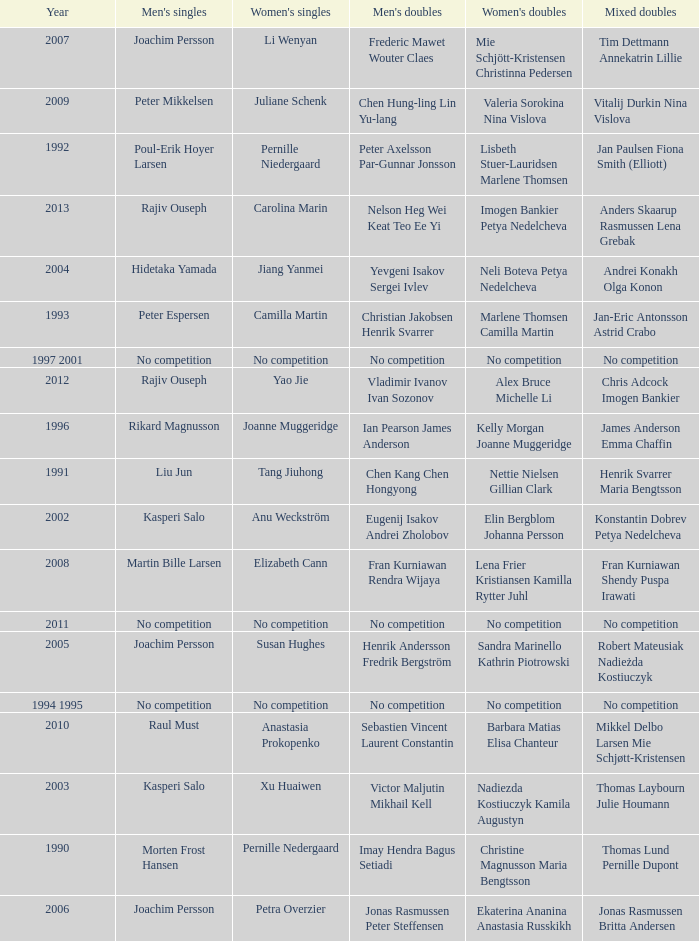Who won the Mixed doubles when Juliane Schenk won the Women's Singles? Vitalij Durkin Nina Vislova. 